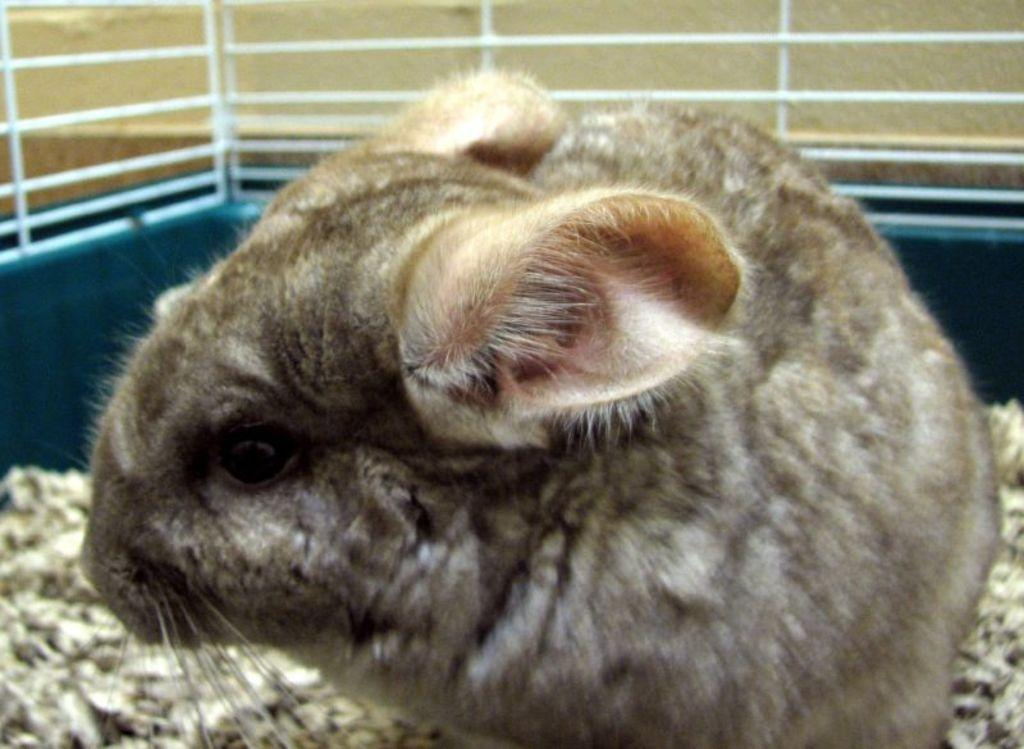What type of animal can be seen in the image? There is an animal in the image, but its specific type cannot be determined from the provided facts. Where is the animal located in the image? The animal is on the land in the image. What can be seen in the background of the image? There is a metal rod visible in the background of the image, and the background has a cream color. What type of lumber is being used to build the school in the image? There is no school or lumber present in the image; it features an animal on the land with a metal rod and a cream-colored background. Can you tell me what type of guitar the animal is playing in the image? There is no guitar or indication of music in the image; it only shows an animal on the land with a metal rod and a cream-colored background. 